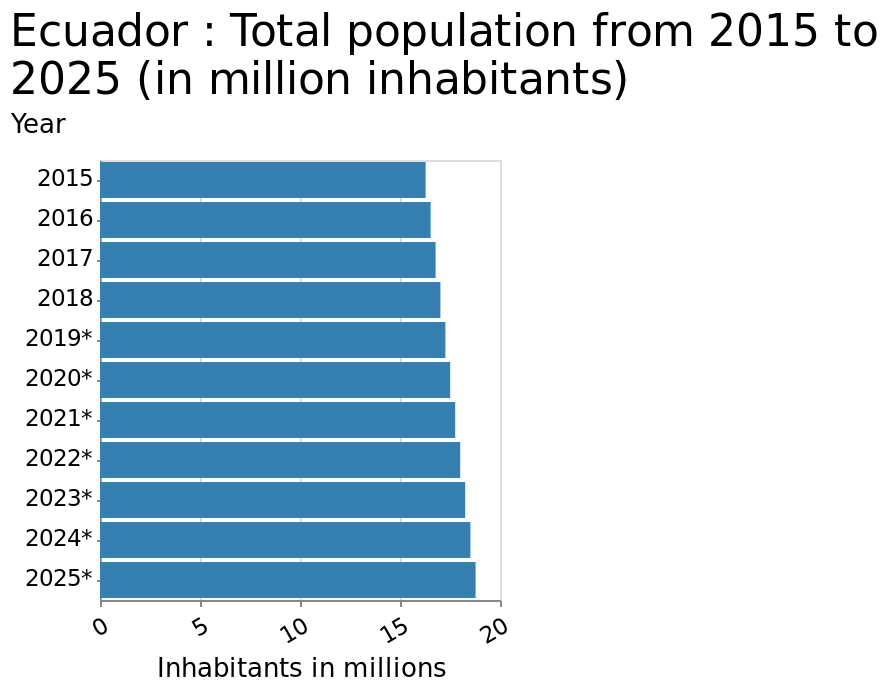<image>
What is the maximum value on the x-axis of the bar chart?  The maximum value on the x-axis is 20. please summary the statistics and relations of the chart We can see a steady increase in inhabitants in millions. In 2015 the population was about 16 million and prediction for 2025 is to be around 18 million. Will there be a decrease in population between 2015 and 2025? No, there is an expected increase in population between 2015 and 2025. please enumerates aspects of the construction of the chart Ecuador : Total population from 2015 to 2025 (in million inhabitants) is a bar chart. A categorical scale starting with 2015 and ending with 2025* can be seen on the y-axis, labeled Year. A linear scale with a minimum of 0 and a maximum of 20 can be found along the x-axis, marked Inhabitants in millions. 